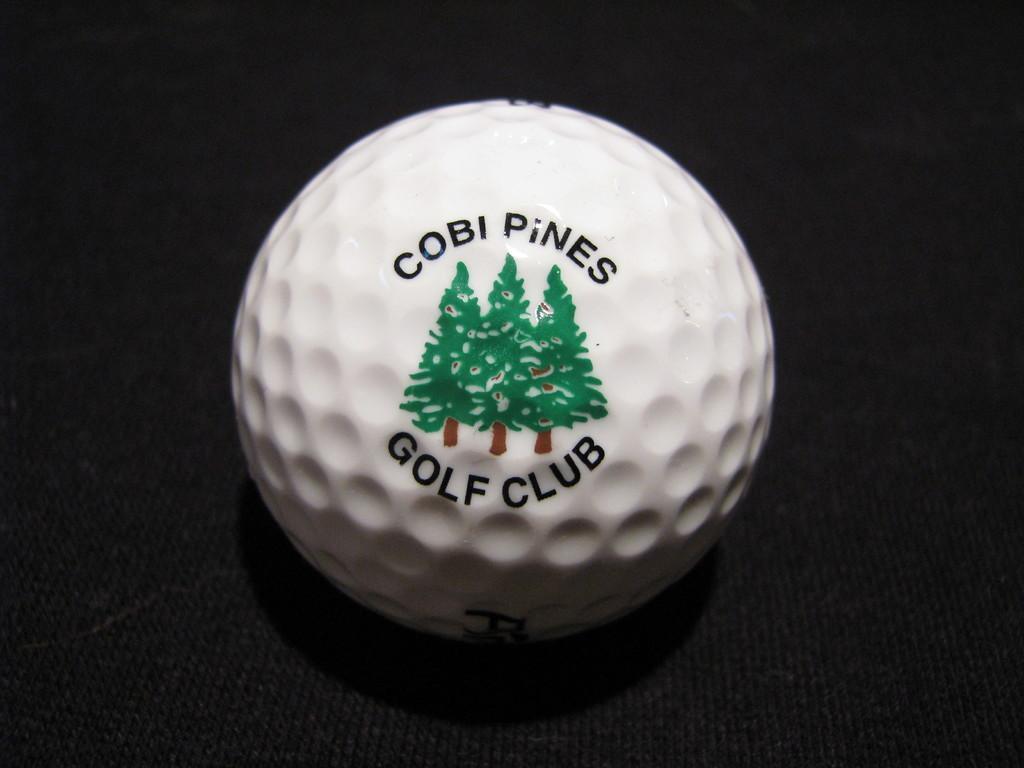Please provide a concise description of this image. In this picture I can see a ball at the center, there is the text and a painting on it. 